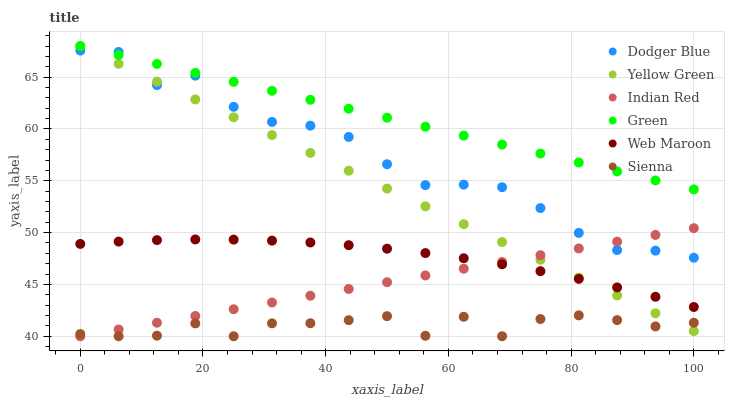Does Sienna have the minimum area under the curve?
Answer yes or no. Yes. Does Green have the maximum area under the curve?
Answer yes or no. Yes. Does Web Maroon have the minimum area under the curve?
Answer yes or no. No. Does Web Maroon have the maximum area under the curve?
Answer yes or no. No. Is Green the smoothest?
Answer yes or no. Yes. Is Sienna the roughest?
Answer yes or no. Yes. Is Web Maroon the smoothest?
Answer yes or no. No. Is Web Maroon the roughest?
Answer yes or no. No. Does Sienna have the lowest value?
Answer yes or no. Yes. Does Web Maroon have the lowest value?
Answer yes or no. No. Does Green have the highest value?
Answer yes or no. Yes. Does Web Maroon have the highest value?
Answer yes or no. No. Is Web Maroon less than Green?
Answer yes or no. Yes. Is Dodger Blue greater than Sienna?
Answer yes or no. Yes. Does Yellow Green intersect Green?
Answer yes or no. Yes. Is Yellow Green less than Green?
Answer yes or no. No. Is Yellow Green greater than Green?
Answer yes or no. No. Does Web Maroon intersect Green?
Answer yes or no. No. 